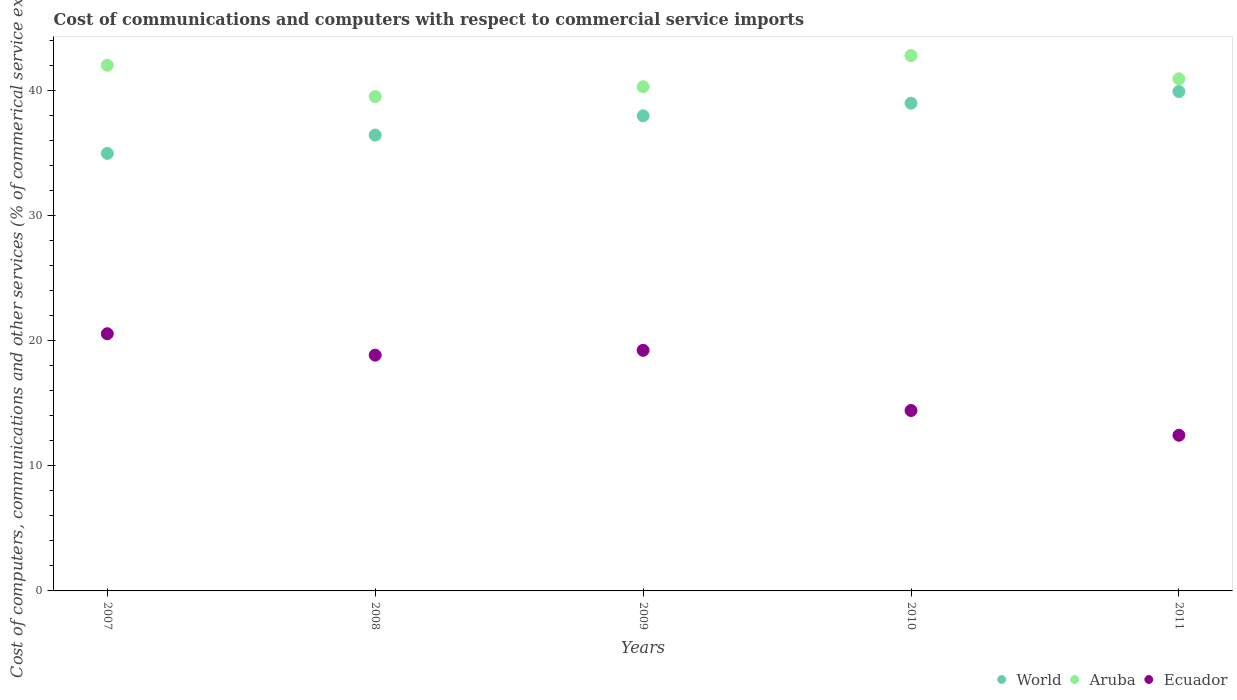How many different coloured dotlines are there?
Offer a very short reply. 3. What is the cost of communications and computers in Aruba in 2009?
Your response must be concise. 40.3. Across all years, what is the maximum cost of communications and computers in Aruba?
Your answer should be compact. 42.79. Across all years, what is the minimum cost of communications and computers in Ecuador?
Provide a short and direct response. 12.44. In which year was the cost of communications and computers in Aruba maximum?
Provide a succinct answer. 2010. What is the total cost of communications and computers in Aruba in the graph?
Offer a terse response. 205.54. What is the difference between the cost of communications and computers in Aruba in 2008 and that in 2011?
Make the answer very short. -1.42. What is the difference between the cost of communications and computers in Aruba in 2011 and the cost of communications and computers in Ecuador in 2010?
Make the answer very short. 26.51. What is the average cost of communications and computers in World per year?
Offer a terse response. 37.65. In the year 2008, what is the difference between the cost of communications and computers in Ecuador and cost of communications and computers in Aruba?
Offer a terse response. -20.67. What is the ratio of the cost of communications and computers in World in 2007 to that in 2010?
Offer a terse response. 0.9. Is the difference between the cost of communications and computers in Ecuador in 2007 and 2011 greater than the difference between the cost of communications and computers in Aruba in 2007 and 2011?
Offer a very short reply. Yes. What is the difference between the highest and the second highest cost of communications and computers in World?
Provide a succinct answer. 0.93. What is the difference between the highest and the lowest cost of communications and computers in Aruba?
Your answer should be very brief. 3.28. In how many years, is the cost of communications and computers in Ecuador greater than the average cost of communications and computers in Ecuador taken over all years?
Provide a succinct answer. 3. Is the sum of the cost of communications and computers in World in 2007 and 2010 greater than the maximum cost of communications and computers in Ecuador across all years?
Keep it short and to the point. Yes. Is it the case that in every year, the sum of the cost of communications and computers in Ecuador and cost of communications and computers in World  is greater than the cost of communications and computers in Aruba?
Offer a very short reply. Yes. Does the cost of communications and computers in Aruba monotonically increase over the years?
Your answer should be compact. No. Is the cost of communications and computers in Ecuador strictly less than the cost of communications and computers in Aruba over the years?
Your answer should be very brief. Yes. How many years are there in the graph?
Make the answer very short. 5. What is the difference between two consecutive major ticks on the Y-axis?
Offer a terse response. 10. Does the graph contain any zero values?
Offer a very short reply. No. Does the graph contain grids?
Ensure brevity in your answer.  No. Where does the legend appear in the graph?
Make the answer very short. Bottom right. How many legend labels are there?
Ensure brevity in your answer.  3. How are the legend labels stacked?
Your answer should be compact. Horizontal. What is the title of the graph?
Make the answer very short. Cost of communications and computers with respect to commercial service imports. Does "China" appear as one of the legend labels in the graph?
Offer a terse response. No. What is the label or title of the Y-axis?
Offer a terse response. Cost of computers, communications and other services (% of commerical service exports). What is the Cost of computers, communications and other services (% of commerical service exports) of World in 2007?
Offer a very short reply. 34.97. What is the Cost of computers, communications and other services (% of commerical service exports) in Aruba in 2007?
Provide a short and direct response. 42.01. What is the Cost of computers, communications and other services (% of commerical service exports) of Ecuador in 2007?
Make the answer very short. 20.55. What is the Cost of computers, communications and other services (% of commerical service exports) in World in 2008?
Your answer should be very brief. 36.43. What is the Cost of computers, communications and other services (% of commerical service exports) in Aruba in 2008?
Keep it short and to the point. 39.51. What is the Cost of computers, communications and other services (% of commerical service exports) in Ecuador in 2008?
Ensure brevity in your answer.  18.84. What is the Cost of computers, communications and other services (% of commerical service exports) in World in 2009?
Provide a short and direct response. 37.97. What is the Cost of computers, communications and other services (% of commerical service exports) in Aruba in 2009?
Provide a succinct answer. 40.3. What is the Cost of computers, communications and other services (% of commerical service exports) of Ecuador in 2009?
Offer a very short reply. 19.23. What is the Cost of computers, communications and other services (% of commerical service exports) of World in 2010?
Keep it short and to the point. 38.98. What is the Cost of computers, communications and other services (% of commerical service exports) in Aruba in 2010?
Your answer should be very brief. 42.79. What is the Cost of computers, communications and other services (% of commerical service exports) of Ecuador in 2010?
Provide a short and direct response. 14.42. What is the Cost of computers, communications and other services (% of commerical service exports) of World in 2011?
Provide a short and direct response. 39.91. What is the Cost of computers, communications and other services (% of commerical service exports) in Aruba in 2011?
Offer a terse response. 40.93. What is the Cost of computers, communications and other services (% of commerical service exports) of Ecuador in 2011?
Ensure brevity in your answer.  12.44. Across all years, what is the maximum Cost of computers, communications and other services (% of commerical service exports) of World?
Offer a very short reply. 39.91. Across all years, what is the maximum Cost of computers, communications and other services (% of commerical service exports) of Aruba?
Make the answer very short. 42.79. Across all years, what is the maximum Cost of computers, communications and other services (% of commerical service exports) of Ecuador?
Give a very brief answer. 20.55. Across all years, what is the minimum Cost of computers, communications and other services (% of commerical service exports) in World?
Offer a very short reply. 34.97. Across all years, what is the minimum Cost of computers, communications and other services (% of commerical service exports) of Aruba?
Provide a succinct answer. 39.51. Across all years, what is the minimum Cost of computers, communications and other services (% of commerical service exports) of Ecuador?
Your answer should be very brief. 12.44. What is the total Cost of computers, communications and other services (% of commerical service exports) of World in the graph?
Provide a succinct answer. 188.26. What is the total Cost of computers, communications and other services (% of commerical service exports) in Aruba in the graph?
Offer a terse response. 205.54. What is the total Cost of computers, communications and other services (% of commerical service exports) of Ecuador in the graph?
Offer a very short reply. 85.49. What is the difference between the Cost of computers, communications and other services (% of commerical service exports) in World in 2007 and that in 2008?
Your response must be concise. -1.47. What is the difference between the Cost of computers, communications and other services (% of commerical service exports) in Aruba in 2007 and that in 2008?
Your answer should be very brief. 2.51. What is the difference between the Cost of computers, communications and other services (% of commerical service exports) of Ecuador in 2007 and that in 2008?
Keep it short and to the point. 1.71. What is the difference between the Cost of computers, communications and other services (% of commerical service exports) of World in 2007 and that in 2009?
Make the answer very short. -3. What is the difference between the Cost of computers, communications and other services (% of commerical service exports) of Aruba in 2007 and that in 2009?
Offer a very short reply. 1.72. What is the difference between the Cost of computers, communications and other services (% of commerical service exports) in Ecuador in 2007 and that in 2009?
Offer a very short reply. 1.33. What is the difference between the Cost of computers, communications and other services (% of commerical service exports) in World in 2007 and that in 2010?
Keep it short and to the point. -4.01. What is the difference between the Cost of computers, communications and other services (% of commerical service exports) in Aruba in 2007 and that in 2010?
Your answer should be compact. -0.77. What is the difference between the Cost of computers, communications and other services (% of commerical service exports) in Ecuador in 2007 and that in 2010?
Offer a terse response. 6.13. What is the difference between the Cost of computers, communications and other services (% of commerical service exports) of World in 2007 and that in 2011?
Give a very brief answer. -4.94. What is the difference between the Cost of computers, communications and other services (% of commerical service exports) of Aruba in 2007 and that in 2011?
Offer a very short reply. 1.08. What is the difference between the Cost of computers, communications and other services (% of commerical service exports) in Ecuador in 2007 and that in 2011?
Give a very brief answer. 8.11. What is the difference between the Cost of computers, communications and other services (% of commerical service exports) in World in 2008 and that in 2009?
Give a very brief answer. -1.54. What is the difference between the Cost of computers, communications and other services (% of commerical service exports) of Aruba in 2008 and that in 2009?
Ensure brevity in your answer.  -0.79. What is the difference between the Cost of computers, communications and other services (% of commerical service exports) of Ecuador in 2008 and that in 2009?
Your answer should be compact. -0.39. What is the difference between the Cost of computers, communications and other services (% of commerical service exports) in World in 2008 and that in 2010?
Ensure brevity in your answer.  -2.55. What is the difference between the Cost of computers, communications and other services (% of commerical service exports) in Aruba in 2008 and that in 2010?
Make the answer very short. -3.28. What is the difference between the Cost of computers, communications and other services (% of commerical service exports) in Ecuador in 2008 and that in 2010?
Your answer should be compact. 4.42. What is the difference between the Cost of computers, communications and other services (% of commerical service exports) in World in 2008 and that in 2011?
Offer a very short reply. -3.48. What is the difference between the Cost of computers, communications and other services (% of commerical service exports) in Aruba in 2008 and that in 2011?
Keep it short and to the point. -1.42. What is the difference between the Cost of computers, communications and other services (% of commerical service exports) of Ecuador in 2008 and that in 2011?
Ensure brevity in your answer.  6.4. What is the difference between the Cost of computers, communications and other services (% of commerical service exports) in World in 2009 and that in 2010?
Offer a terse response. -1.01. What is the difference between the Cost of computers, communications and other services (% of commerical service exports) in Aruba in 2009 and that in 2010?
Your answer should be compact. -2.49. What is the difference between the Cost of computers, communications and other services (% of commerical service exports) of Ecuador in 2009 and that in 2010?
Keep it short and to the point. 4.81. What is the difference between the Cost of computers, communications and other services (% of commerical service exports) in World in 2009 and that in 2011?
Give a very brief answer. -1.94. What is the difference between the Cost of computers, communications and other services (% of commerical service exports) of Aruba in 2009 and that in 2011?
Provide a succinct answer. -0.64. What is the difference between the Cost of computers, communications and other services (% of commerical service exports) of Ecuador in 2009 and that in 2011?
Keep it short and to the point. 6.79. What is the difference between the Cost of computers, communications and other services (% of commerical service exports) in World in 2010 and that in 2011?
Your response must be concise. -0.93. What is the difference between the Cost of computers, communications and other services (% of commerical service exports) in Aruba in 2010 and that in 2011?
Provide a succinct answer. 1.86. What is the difference between the Cost of computers, communications and other services (% of commerical service exports) in Ecuador in 2010 and that in 2011?
Offer a terse response. 1.98. What is the difference between the Cost of computers, communications and other services (% of commerical service exports) in World in 2007 and the Cost of computers, communications and other services (% of commerical service exports) in Aruba in 2008?
Offer a terse response. -4.54. What is the difference between the Cost of computers, communications and other services (% of commerical service exports) of World in 2007 and the Cost of computers, communications and other services (% of commerical service exports) of Ecuador in 2008?
Give a very brief answer. 16.13. What is the difference between the Cost of computers, communications and other services (% of commerical service exports) of Aruba in 2007 and the Cost of computers, communications and other services (% of commerical service exports) of Ecuador in 2008?
Give a very brief answer. 23.17. What is the difference between the Cost of computers, communications and other services (% of commerical service exports) of World in 2007 and the Cost of computers, communications and other services (% of commerical service exports) of Aruba in 2009?
Keep it short and to the point. -5.33. What is the difference between the Cost of computers, communications and other services (% of commerical service exports) in World in 2007 and the Cost of computers, communications and other services (% of commerical service exports) in Ecuador in 2009?
Make the answer very short. 15.74. What is the difference between the Cost of computers, communications and other services (% of commerical service exports) of Aruba in 2007 and the Cost of computers, communications and other services (% of commerical service exports) of Ecuador in 2009?
Keep it short and to the point. 22.78. What is the difference between the Cost of computers, communications and other services (% of commerical service exports) in World in 2007 and the Cost of computers, communications and other services (% of commerical service exports) in Aruba in 2010?
Offer a terse response. -7.82. What is the difference between the Cost of computers, communications and other services (% of commerical service exports) of World in 2007 and the Cost of computers, communications and other services (% of commerical service exports) of Ecuador in 2010?
Offer a terse response. 20.55. What is the difference between the Cost of computers, communications and other services (% of commerical service exports) of Aruba in 2007 and the Cost of computers, communications and other services (% of commerical service exports) of Ecuador in 2010?
Offer a terse response. 27.59. What is the difference between the Cost of computers, communications and other services (% of commerical service exports) of World in 2007 and the Cost of computers, communications and other services (% of commerical service exports) of Aruba in 2011?
Your answer should be compact. -5.96. What is the difference between the Cost of computers, communications and other services (% of commerical service exports) in World in 2007 and the Cost of computers, communications and other services (% of commerical service exports) in Ecuador in 2011?
Keep it short and to the point. 22.53. What is the difference between the Cost of computers, communications and other services (% of commerical service exports) of Aruba in 2007 and the Cost of computers, communications and other services (% of commerical service exports) of Ecuador in 2011?
Give a very brief answer. 29.57. What is the difference between the Cost of computers, communications and other services (% of commerical service exports) in World in 2008 and the Cost of computers, communications and other services (% of commerical service exports) in Aruba in 2009?
Your response must be concise. -3.86. What is the difference between the Cost of computers, communications and other services (% of commerical service exports) of World in 2008 and the Cost of computers, communications and other services (% of commerical service exports) of Ecuador in 2009?
Provide a succinct answer. 17.2. What is the difference between the Cost of computers, communications and other services (% of commerical service exports) in Aruba in 2008 and the Cost of computers, communications and other services (% of commerical service exports) in Ecuador in 2009?
Your response must be concise. 20.28. What is the difference between the Cost of computers, communications and other services (% of commerical service exports) in World in 2008 and the Cost of computers, communications and other services (% of commerical service exports) in Aruba in 2010?
Offer a very short reply. -6.35. What is the difference between the Cost of computers, communications and other services (% of commerical service exports) of World in 2008 and the Cost of computers, communications and other services (% of commerical service exports) of Ecuador in 2010?
Your answer should be very brief. 22.01. What is the difference between the Cost of computers, communications and other services (% of commerical service exports) in Aruba in 2008 and the Cost of computers, communications and other services (% of commerical service exports) in Ecuador in 2010?
Your answer should be compact. 25.09. What is the difference between the Cost of computers, communications and other services (% of commerical service exports) in World in 2008 and the Cost of computers, communications and other services (% of commerical service exports) in Aruba in 2011?
Offer a very short reply. -4.5. What is the difference between the Cost of computers, communications and other services (% of commerical service exports) of World in 2008 and the Cost of computers, communications and other services (% of commerical service exports) of Ecuador in 2011?
Provide a succinct answer. 23.99. What is the difference between the Cost of computers, communications and other services (% of commerical service exports) of Aruba in 2008 and the Cost of computers, communications and other services (% of commerical service exports) of Ecuador in 2011?
Offer a terse response. 27.07. What is the difference between the Cost of computers, communications and other services (% of commerical service exports) in World in 2009 and the Cost of computers, communications and other services (% of commerical service exports) in Aruba in 2010?
Offer a very short reply. -4.82. What is the difference between the Cost of computers, communications and other services (% of commerical service exports) in World in 2009 and the Cost of computers, communications and other services (% of commerical service exports) in Ecuador in 2010?
Make the answer very short. 23.55. What is the difference between the Cost of computers, communications and other services (% of commerical service exports) in Aruba in 2009 and the Cost of computers, communications and other services (% of commerical service exports) in Ecuador in 2010?
Make the answer very short. 25.88. What is the difference between the Cost of computers, communications and other services (% of commerical service exports) in World in 2009 and the Cost of computers, communications and other services (% of commerical service exports) in Aruba in 2011?
Ensure brevity in your answer.  -2.96. What is the difference between the Cost of computers, communications and other services (% of commerical service exports) in World in 2009 and the Cost of computers, communications and other services (% of commerical service exports) in Ecuador in 2011?
Give a very brief answer. 25.53. What is the difference between the Cost of computers, communications and other services (% of commerical service exports) of Aruba in 2009 and the Cost of computers, communications and other services (% of commerical service exports) of Ecuador in 2011?
Offer a very short reply. 27.86. What is the difference between the Cost of computers, communications and other services (% of commerical service exports) of World in 2010 and the Cost of computers, communications and other services (% of commerical service exports) of Aruba in 2011?
Provide a succinct answer. -1.95. What is the difference between the Cost of computers, communications and other services (% of commerical service exports) in World in 2010 and the Cost of computers, communications and other services (% of commerical service exports) in Ecuador in 2011?
Your response must be concise. 26.54. What is the difference between the Cost of computers, communications and other services (% of commerical service exports) in Aruba in 2010 and the Cost of computers, communications and other services (% of commerical service exports) in Ecuador in 2011?
Provide a succinct answer. 30.35. What is the average Cost of computers, communications and other services (% of commerical service exports) in World per year?
Provide a succinct answer. 37.65. What is the average Cost of computers, communications and other services (% of commerical service exports) in Aruba per year?
Give a very brief answer. 41.11. What is the average Cost of computers, communications and other services (% of commerical service exports) in Ecuador per year?
Your response must be concise. 17.1. In the year 2007, what is the difference between the Cost of computers, communications and other services (% of commerical service exports) in World and Cost of computers, communications and other services (% of commerical service exports) in Aruba?
Your answer should be compact. -7.05. In the year 2007, what is the difference between the Cost of computers, communications and other services (% of commerical service exports) in World and Cost of computers, communications and other services (% of commerical service exports) in Ecuador?
Give a very brief answer. 14.41. In the year 2007, what is the difference between the Cost of computers, communications and other services (% of commerical service exports) of Aruba and Cost of computers, communications and other services (% of commerical service exports) of Ecuador?
Give a very brief answer. 21.46. In the year 2008, what is the difference between the Cost of computers, communications and other services (% of commerical service exports) of World and Cost of computers, communications and other services (% of commerical service exports) of Aruba?
Provide a short and direct response. -3.08. In the year 2008, what is the difference between the Cost of computers, communications and other services (% of commerical service exports) in World and Cost of computers, communications and other services (% of commerical service exports) in Ecuador?
Ensure brevity in your answer.  17.59. In the year 2008, what is the difference between the Cost of computers, communications and other services (% of commerical service exports) of Aruba and Cost of computers, communications and other services (% of commerical service exports) of Ecuador?
Provide a succinct answer. 20.67. In the year 2009, what is the difference between the Cost of computers, communications and other services (% of commerical service exports) of World and Cost of computers, communications and other services (% of commerical service exports) of Aruba?
Ensure brevity in your answer.  -2.33. In the year 2009, what is the difference between the Cost of computers, communications and other services (% of commerical service exports) of World and Cost of computers, communications and other services (% of commerical service exports) of Ecuador?
Your response must be concise. 18.74. In the year 2009, what is the difference between the Cost of computers, communications and other services (% of commerical service exports) in Aruba and Cost of computers, communications and other services (% of commerical service exports) in Ecuador?
Provide a succinct answer. 21.07. In the year 2010, what is the difference between the Cost of computers, communications and other services (% of commerical service exports) of World and Cost of computers, communications and other services (% of commerical service exports) of Aruba?
Provide a short and direct response. -3.81. In the year 2010, what is the difference between the Cost of computers, communications and other services (% of commerical service exports) in World and Cost of computers, communications and other services (% of commerical service exports) in Ecuador?
Keep it short and to the point. 24.56. In the year 2010, what is the difference between the Cost of computers, communications and other services (% of commerical service exports) in Aruba and Cost of computers, communications and other services (% of commerical service exports) in Ecuador?
Provide a succinct answer. 28.37. In the year 2011, what is the difference between the Cost of computers, communications and other services (% of commerical service exports) of World and Cost of computers, communications and other services (% of commerical service exports) of Aruba?
Offer a very short reply. -1.02. In the year 2011, what is the difference between the Cost of computers, communications and other services (% of commerical service exports) in World and Cost of computers, communications and other services (% of commerical service exports) in Ecuador?
Make the answer very short. 27.47. In the year 2011, what is the difference between the Cost of computers, communications and other services (% of commerical service exports) of Aruba and Cost of computers, communications and other services (% of commerical service exports) of Ecuador?
Provide a succinct answer. 28.49. What is the ratio of the Cost of computers, communications and other services (% of commerical service exports) in World in 2007 to that in 2008?
Offer a very short reply. 0.96. What is the ratio of the Cost of computers, communications and other services (% of commerical service exports) in Aruba in 2007 to that in 2008?
Make the answer very short. 1.06. What is the ratio of the Cost of computers, communications and other services (% of commerical service exports) of Ecuador in 2007 to that in 2008?
Your answer should be compact. 1.09. What is the ratio of the Cost of computers, communications and other services (% of commerical service exports) of World in 2007 to that in 2009?
Provide a short and direct response. 0.92. What is the ratio of the Cost of computers, communications and other services (% of commerical service exports) in Aruba in 2007 to that in 2009?
Offer a terse response. 1.04. What is the ratio of the Cost of computers, communications and other services (% of commerical service exports) in Ecuador in 2007 to that in 2009?
Give a very brief answer. 1.07. What is the ratio of the Cost of computers, communications and other services (% of commerical service exports) in World in 2007 to that in 2010?
Provide a succinct answer. 0.9. What is the ratio of the Cost of computers, communications and other services (% of commerical service exports) of Aruba in 2007 to that in 2010?
Offer a terse response. 0.98. What is the ratio of the Cost of computers, communications and other services (% of commerical service exports) in Ecuador in 2007 to that in 2010?
Your response must be concise. 1.43. What is the ratio of the Cost of computers, communications and other services (% of commerical service exports) in World in 2007 to that in 2011?
Your response must be concise. 0.88. What is the ratio of the Cost of computers, communications and other services (% of commerical service exports) of Aruba in 2007 to that in 2011?
Ensure brevity in your answer.  1.03. What is the ratio of the Cost of computers, communications and other services (% of commerical service exports) of Ecuador in 2007 to that in 2011?
Offer a very short reply. 1.65. What is the ratio of the Cost of computers, communications and other services (% of commerical service exports) of World in 2008 to that in 2009?
Your answer should be compact. 0.96. What is the ratio of the Cost of computers, communications and other services (% of commerical service exports) of Aruba in 2008 to that in 2009?
Provide a succinct answer. 0.98. What is the ratio of the Cost of computers, communications and other services (% of commerical service exports) of Ecuador in 2008 to that in 2009?
Give a very brief answer. 0.98. What is the ratio of the Cost of computers, communications and other services (% of commerical service exports) in World in 2008 to that in 2010?
Offer a very short reply. 0.93. What is the ratio of the Cost of computers, communications and other services (% of commerical service exports) of Aruba in 2008 to that in 2010?
Offer a very short reply. 0.92. What is the ratio of the Cost of computers, communications and other services (% of commerical service exports) in Ecuador in 2008 to that in 2010?
Offer a terse response. 1.31. What is the ratio of the Cost of computers, communications and other services (% of commerical service exports) of World in 2008 to that in 2011?
Ensure brevity in your answer.  0.91. What is the ratio of the Cost of computers, communications and other services (% of commerical service exports) of Aruba in 2008 to that in 2011?
Your answer should be compact. 0.97. What is the ratio of the Cost of computers, communications and other services (% of commerical service exports) in Ecuador in 2008 to that in 2011?
Make the answer very short. 1.51. What is the ratio of the Cost of computers, communications and other services (% of commerical service exports) of World in 2009 to that in 2010?
Your answer should be very brief. 0.97. What is the ratio of the Cost of computers, communications and other services (% of commerical service exports) in Aruba in 2009 to that in 2010?
Provide a short and direct response. 0.94. What is the ratio of the Cost of computers, communications and other services (% of commerical service exports) of Ecuador in 2009 to that in 2010?
Ensure brevity in your answer.  1.33. What is the ratio of the Cost of computers, communications and other services (% of commerical service exports) in World in 2009 to that in 2011?
Ensure brevity in your answer.  0.95. What is the ratio of the Cost of computers, communications and other services (% of commerical service exports) of Aruba in 2009 to that in 2011?
Give a very brief answer. 0.98. What is the ratio of the Cost of computers, communications and other services (% of commerical service exports) in Ecuador in 2009 to that in 2011?
Offer a terse response. 1.55. What is the ratio of the Cost of computers, communications and other services (% of commerical service exports) of World in 2010 to that in 2011?
Your response must be concise. 0.98. What is the ratio of the Cost of computers, communications and other services (% of commerical service exports) in Aruba in 2010 to that in 2011?
Offer a very short reply. 1.05. What is the ratio of the Cost of computers, communications and other services (% of commerical service exports) of Ecuador in 2010 to that in 2011?
Provide a short and direct response. 1.16. What is the difference between the highest and the second highest Cost of computers, communications and other services (% of commerical service exports) in Aruba?
Keep it short and to the point. 0.77. What is the difference between the highest and the second highest Cost of computers, communications and other services (% of commerical service exports) in Ecuador?
Provide a short and direct response. 1.33. What is the difference between the highest and the lowest Cost of computers, communications and other services (% of commerical service exports) in World?
Ensure brevity in your answer.  4.94. What is the difference between the highest and the lowest Cost of computers, communications and other services (% of commerical service exports) of Aruba?
Offer a terse response. 3.28. What is the difference between the highest and the lowest Cost of computers, communications and other services (% of commerical service exports) of Ecuador?
Offer a terse response. 8.11. 